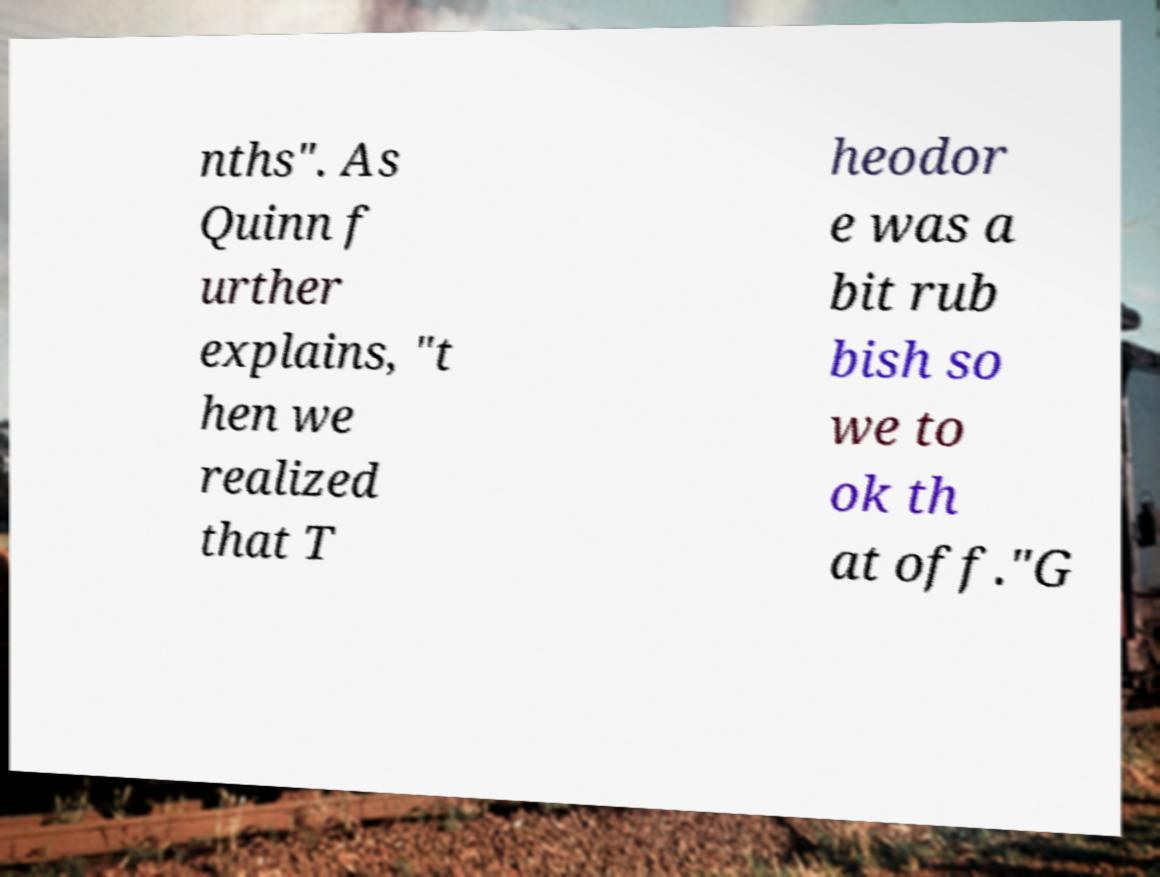Could you assist in decoding the text presented in this image and type it out clearly? nths". As Quinn f urther explains, "t hen we realized that T heodor e was a bit rub bish so we to ok th at off."G 